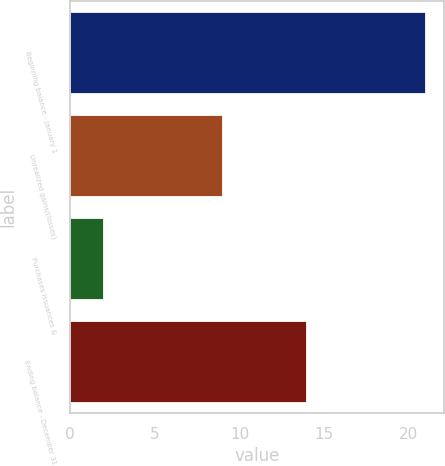<chart> <loc_0><loc_0><loc_500><loc_500><bar_chart><fcel>Beginning balance - January 1<fcel>Unrealized gains/(losses)<fcel>Purchases issuances &<fcel>Ending balance - December 31<nl><fcel>21<fcel>9<fcel>2<fcel>14<nl></chart> 